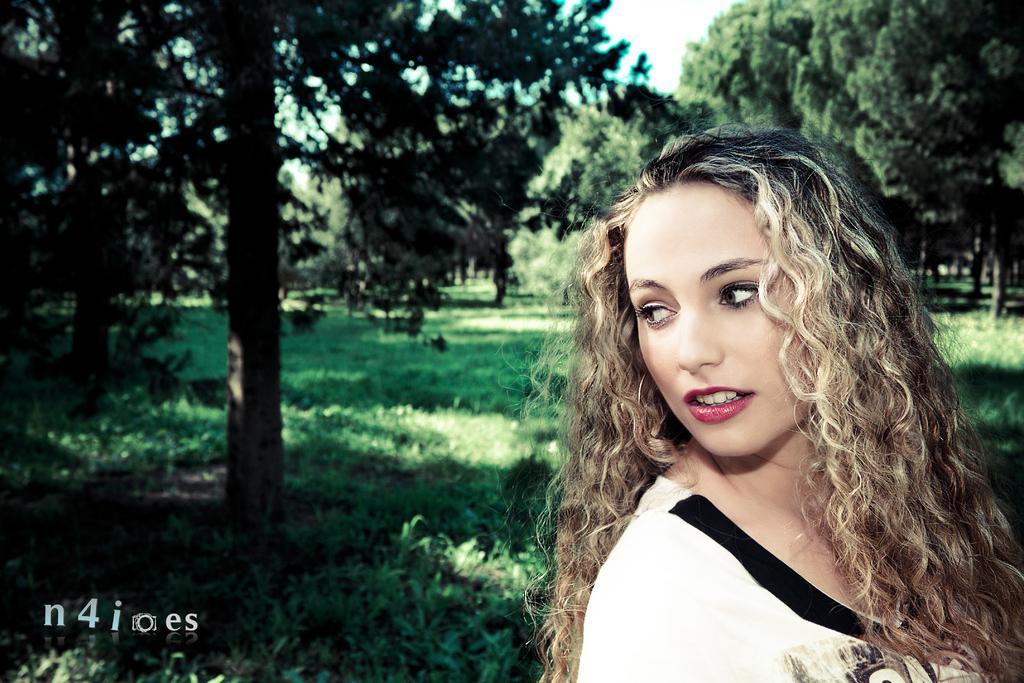How would you summarize this image in a sentence or two? In this image I can see a person wearing white and black dress. I can see few trees. The sky is in white color. 